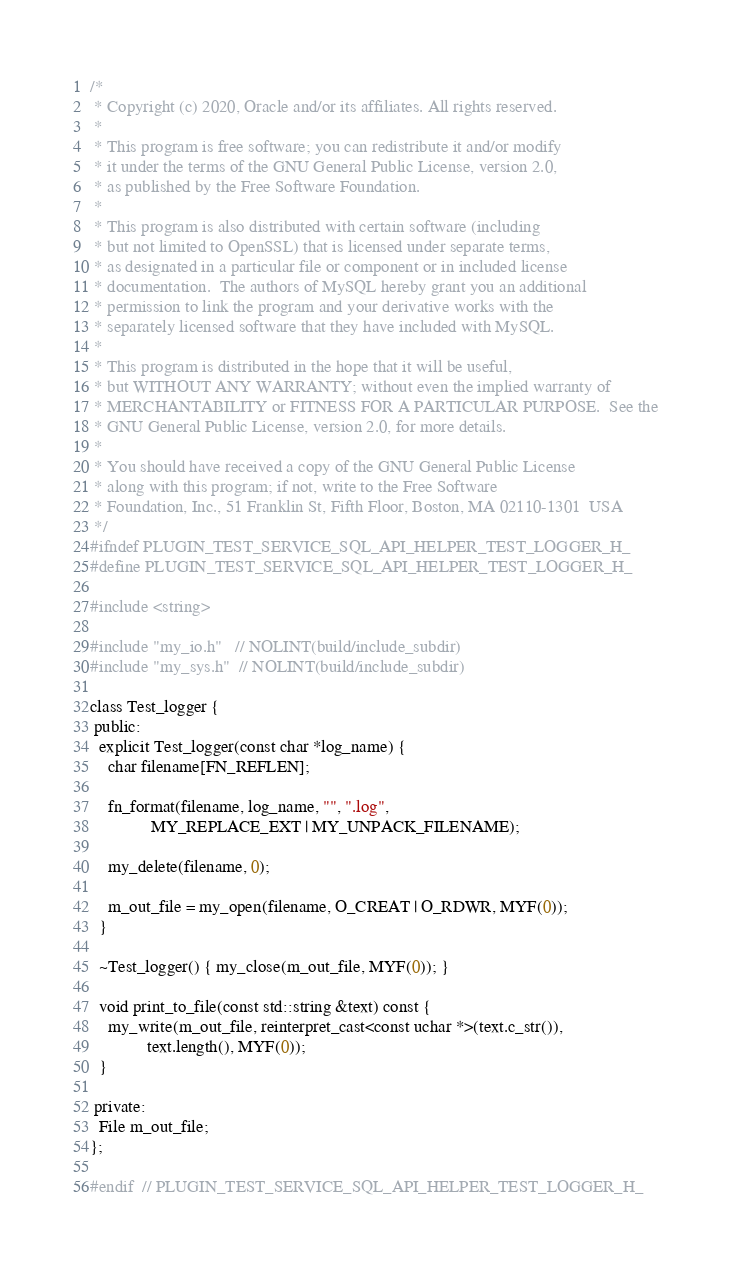Convert code to text. <code><loc_0><loc_0><loc_500><loc_500><_C_>/*
 * Copyright (c) 2020, Oracle and/or its affiliates. All rights reserved.
 *
 * This program is free software; you can redistribute it and/or modify
 * it under the terms of the GNU General Public License, version 2.0,
 * as published by the Free Software Foundation.
 *
 * This program is also distributed with certain software (including
 * but not limited to OpenSSL) that is licensed under separate terms,
 * as designated in a particular file or component or in included license
 * documentation.  The authors of MySQL hereby grant you an additional
 * permission to link the program and your derivative works with the
 * separately licensed software that they have included with MySQL.
 *
 * This program is distributed in the hope that it will be useful,
 * but WITHOUT ANY WARRANTY; without even the implied warranty of
 * MERCHANTABILITY or FITNESS FOR A PARTICULAR PURPOSE.  See the
 * GNU General Public License, version 2.0, for more details.
 *
 * You should have received a copy of the GNU General Public License
 * along with this program; if not, write to the Free Software
 * Foundation, Inc., 51 Franklin St, Fifth Floor, Boston, MA 02110-1301  USA
 */
#ifndef PLUGIN_TEST_SERVICE_SQL_API_HELPER_TEST_LOGGER_H_
#define PLUGIN_TEST_SERVICE_SQL_API_HELPER_TEST_LOGGER_H_

#include <string>

#include "my_io.h"   // NOLINT(build/include_subdir)
#include "my_sys.h"  // NOLINT(build/include_subdir)

class Test_logger {
 public:
  explicit Test_logger(const char *log_name) {
    char filename[FN_REFLEN];

    fn_format(filename, log_name, "", ".log",
              MY_REPLACE_EXT | MY_UNPACK_FILENAME);

    my_delete(filename, 0);

    m_out_file = my_open(filename, O_CREAT | O_RDWR, MYF(0));
  }

  ~Test_logger() { my_close(m_out_file, MYF(0)); }

  void print_to_file(const std::string &text) const {
    my_write(m_out_file, reinterpret_cast<const uchar *>(text.c_str()),
             text.length(), MYF(0));
  }

 private:
  File m_out_file;
};

#endif  // PLUGIN_TEST_SERVICE_SQL_API_HELPER_TEST_LOGGER_H_
</code> 